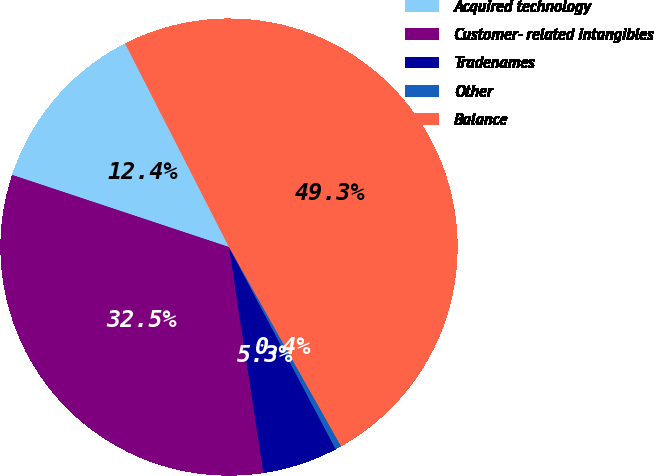<chart> <loc_0><loc_0><loc_500><loc_500><pie_chart><fcel>Acquired technology<fcel>Customer- related intangibles<fcel>Tradenames<fcel>Other<fcel>Balance<nl><fcel>12.38%<fcel>32.52%<fcel>5.32%<fcel>0.43%<fcel>49.35%<nl></chart> 